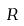<formula> <loc_0><loc_0><loc_500><loc_500>R</formula> 